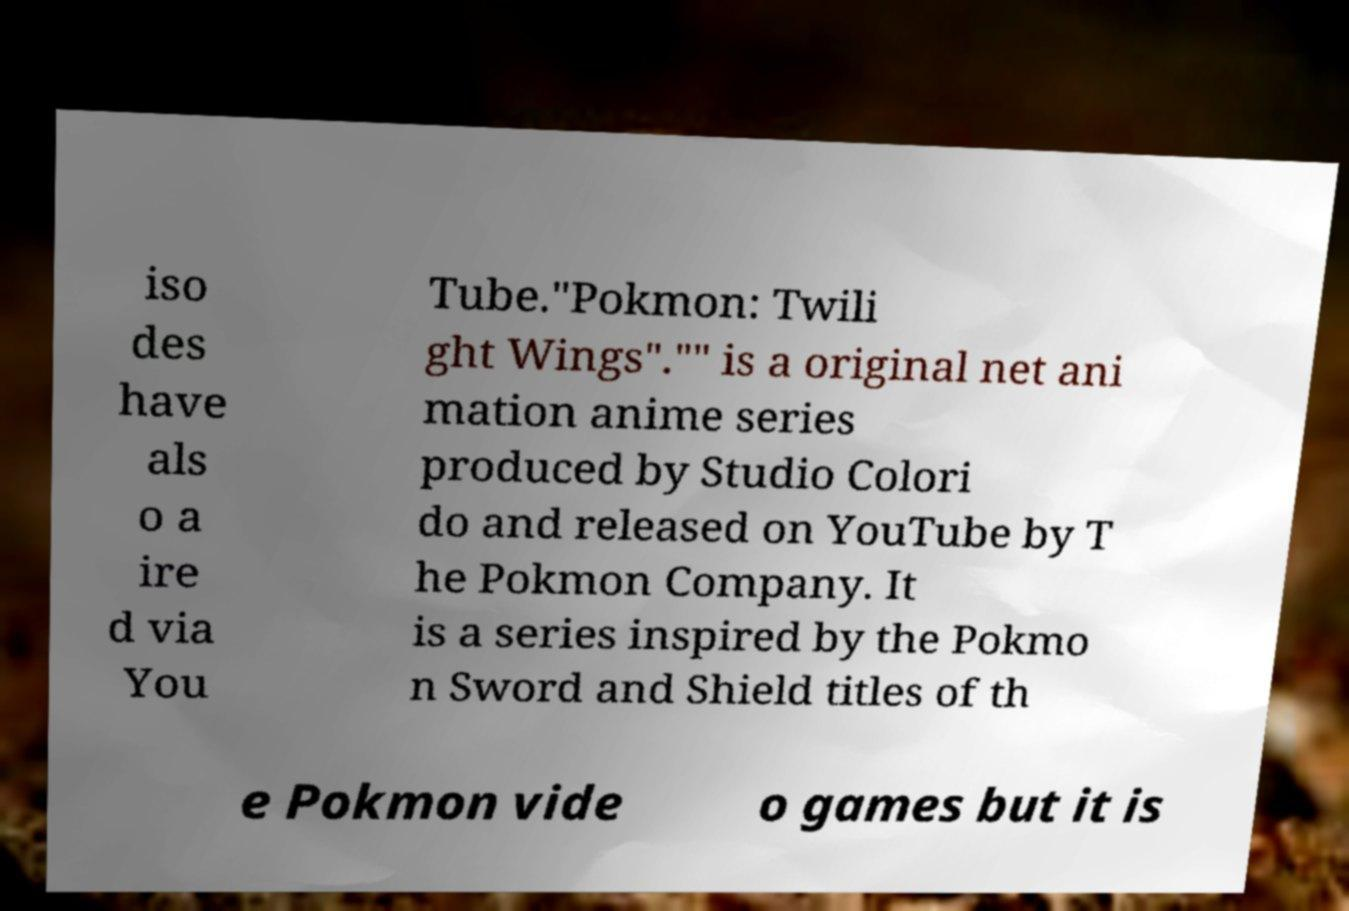Can you accurately transcribe the text from the provided image for me? iso des have als o a ire d via You Tube."Pokmon: Twili ght Wings"."" is a original net ani mation anime series produced by Studio Colori do and released on YouTube by T he Pokmon Company. It is a series inspired by the Pokmo n Sword and Shield titles of th e Pokmon vide o games but it is 